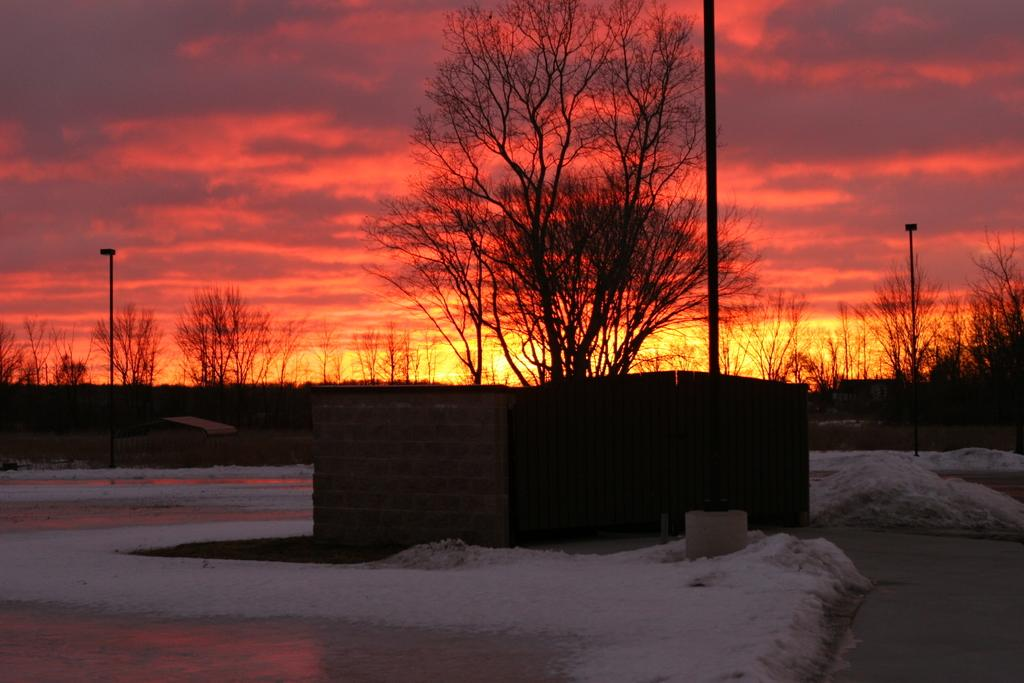What is the color of the sky in the image? The sky in the image has a reddish color. What type of vegetation can be seen in the image? There are many trees in the image. What is covering the ground in the image? There is snow on the ground in the image. What type of library can be seen in the image? There is no library present in the image; it features a reddish sky, trees, and snow on the ground. What is the voice of the person celebrating their birthday in the image? There is no person celebrating their birthday present in the image. 